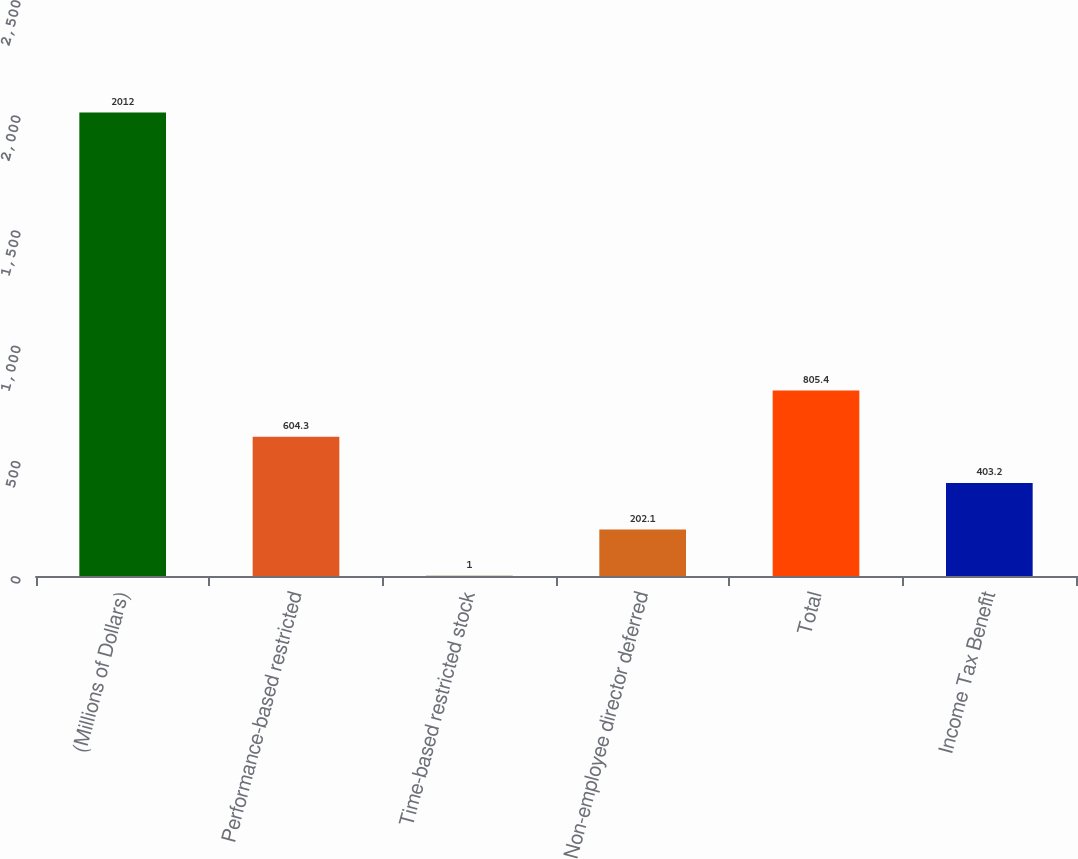<chart> <loc_0><loc_0><loc_500><loc_500><bar_chart><fcel>(Millions of Dollars)<fcel>Performance-based restricted<fcel>Time-based restricted stock<fcel>Non-employee director deferred<fcel>Total<fcel>Income Tax Benefit<nl><fcel>2012<fcel>604.3<fcel>1<fcel>202.1<fcel>805.4<fcel>403.2<nl></chart> 